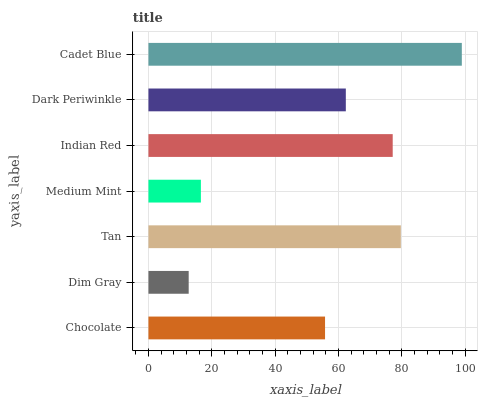Is Dim Gray the minimum?
Answer yes or no. Yes. Is Cadet Blue the maximum?
Answer yes or no. Yes. Is Tan the minimum?
Answer yes or no. No. Is Tan the maximum?
Answer yes or no. No. Is Tan greater than Dim Gray?
Answer yes or no. Yes. Is Dim Gray less than Tan?
Answer yes or no. Yes. Is Dim Gray greater than Tan?
Answer yes or no. No. Is Tan less than Dim Gray?
Answer yes or no. No. Is Dark Periwinkle the high median?
Answer yes or no. Yes. Is Dark Periwinkle the low median?
Answer yes or no. Yes. Is Dim Gray the high median?
Answer yes or no. No. Is Tan the low median?
Answer yes or no. No. 